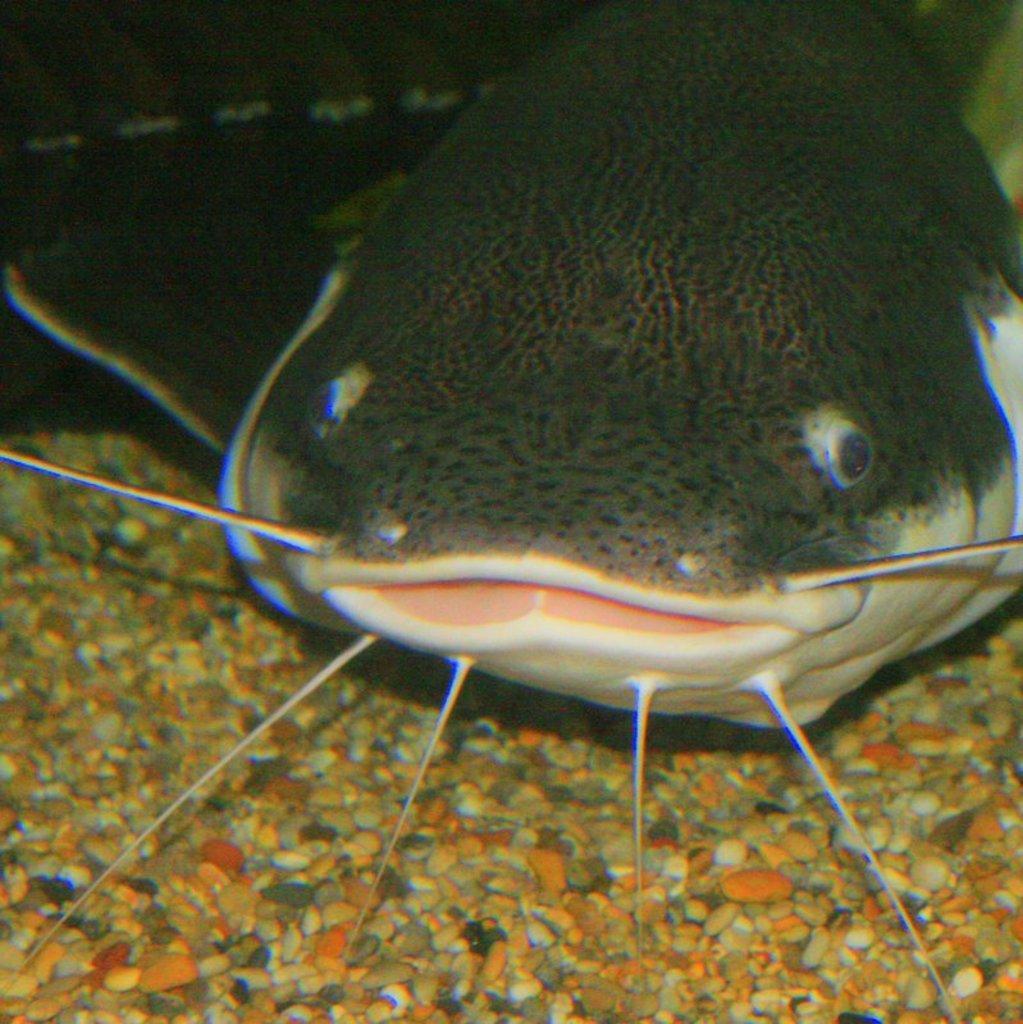In one or two sentences, can you explain what this image depicts? In this picture we can see a fish and some stones and in the background we can see it is dark. 